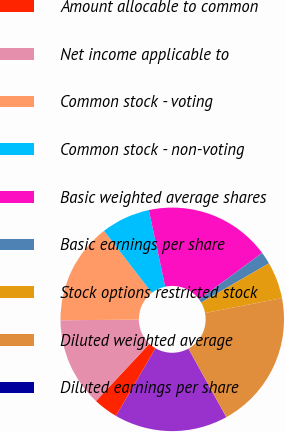Convert chart to OTSL. <chart><loc_0><loc_0><loc_500><loc_500><pie_chart><fcel>Net income<fcel>Amount allocable to common<fcel>Net income applicable to<fcel>Common stock - voting<fcel>Common stock - non-voting<fcel>Basic weighted average shares<fcel>Basic earnings per share<fcel>Stock options restricted stock<fcel>Diluted weighted average<fcel>Diluted earnings per share<nl><fcel>16.45%<fcel>3.55%<fcel>12.91%<fcel>14.68%<fcel>7.09%<fcel>18.23%<fcel>1.77%<fcel>5.32%<fcel>20.0%<fcel>0.0%<nl></chart> 